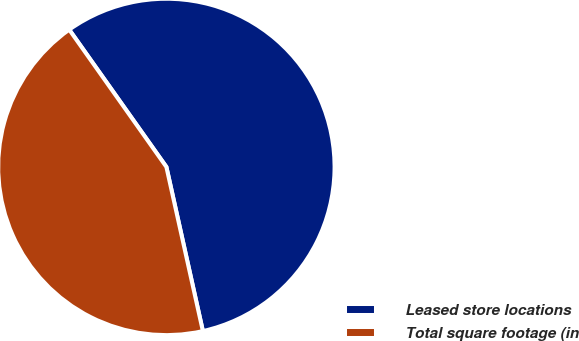<chart> <loc_0><loc_0><loc_500><loc_500><pie_chart><fcel>Leased store locations<fcel>Total square footage (in<nl><fcel>56.32%<fcel>43.68%<nl></chart> 